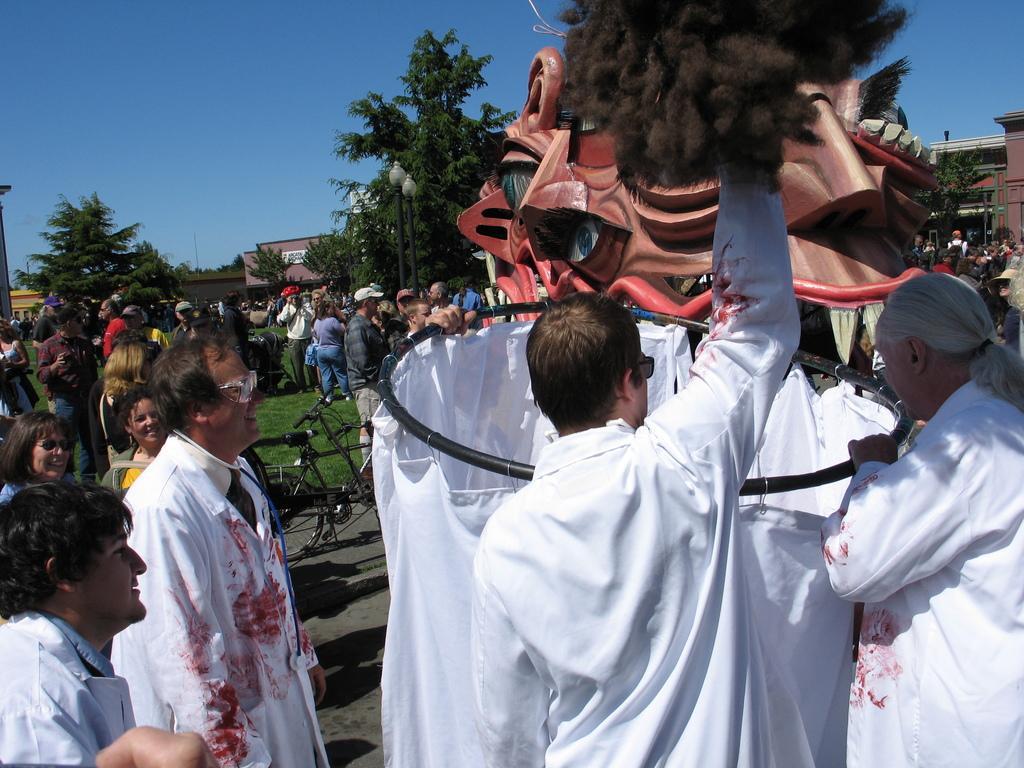Can you describe this image briefly? In this image there are few people and there is a depiction of a dinosaur. In the background there are trees and buildings. 